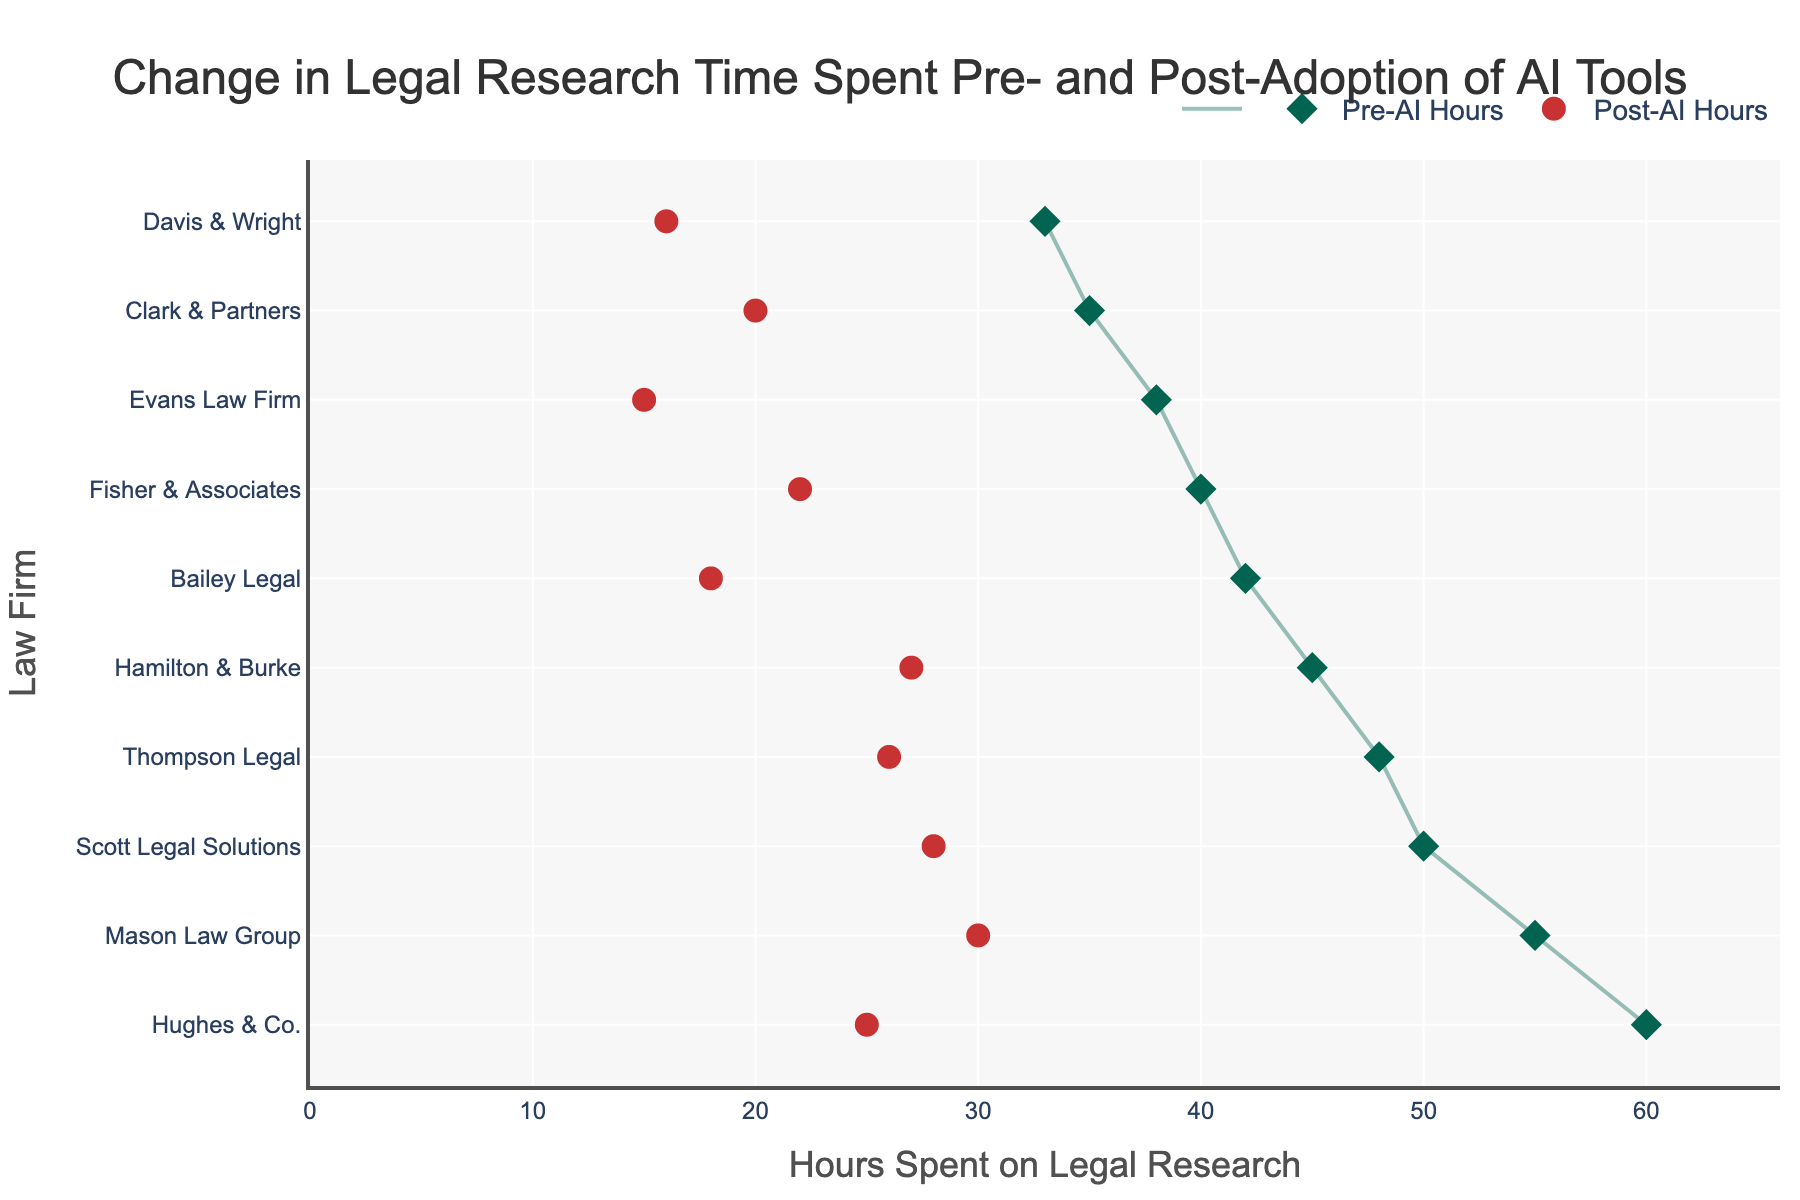What is the title of the plot? The title is located at the top of the plot and reads "Change in Legal Research Time Spent Pre- and Post-Adoption of AI Tools".
Answer: Change in Legal Research Time Spent Pre- and Post-Adoption of AI Tools How many law firms are displayed in the plot? By counting the y-axis labels, we can see there are 10 law firms listed.
Answer: 10 Which law firm experienced the largest reduction in hours spent on legal research after adopting AI tools? Compare the "Pre-AI Hours" and "Post-AI Hours" values for each firm to see the differences. The firm with the largest reduction is Hughes & Co., decreasing from 60 hours to 25 hours, a reduction of 35 hours.
Answer: Hughes & Co What are the colors of the markers representing Pre-AI Hours and Post-AI Hours? By observing the markers, the Pre-AI Hours are represented by green diamonds, and the Post-AI Hours are represented by red circles.
Answer: Green and Red What is the total amount of hours saved for Fisher & Associates after adopting AI tools? Subtract the Post-AI Hours from the Pre-AI Hours for Fisher & Associates: 40 - 22 = 18 hours.
Answer: 18 hours Which law firm had the lowest number of post-AI hours? By checking the x-axis values for "Post-AI Hours", Davis & Wright had the lowest number with 16 hours.
Answer: Davis & Wright What is the average reduction in hours spent on legal research across all firms after adopting AI tools? Calculate the average by taking the sum of the reductions for each firm and dividing by the total number of firms: (15 + 18 + 25 + 35 + 24 + 17 + 23 + 22 + 18 + 22) / 10 = 21.
Answer: 21 Which two law firms had the closest number of post-AI hours? Compare the "Post-AI Hours" values to see which are closest. Scott Legal Solutions and Hamilton & Burke both have 27 and 28 hours, respectively, with a difference of only 1 hour.
Answer: Scott Legal Solutions and Hamilton & Burke What is the range of hours spent on legal research post-AI adoption? Identify the minimum and maximum values of the "Post-AI Hours"; the range is the difference between these values: 27 (Hamilton & Burke) - 15 (Evans Law Firm) = 12.
Answer: 12 Does any law firm spend more than half the amount of their Pre-AI Hours after AI adoption? Compare each firm's "Post-AI Hours" to half of their "Pre-AI Hours"; none of the firms have post-AI hours that exceed half of their pre-AI hours.
Answer: No 